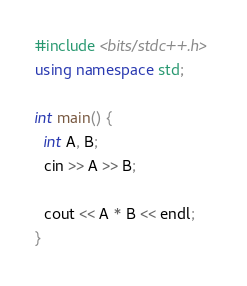Convert code to text. <code><loc_0><loc_0><loc_500><loc_500><_C++_>#include <bits/stdc++.h>
using namespace std;

int main() {
  int A, B;
  cin >> A >> B;
  
  cout << A * B << endl;
}</code> 